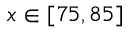<formula> <loc_0><loc_0><loc_500><loc_500>x \in [ 7 5 , 8 5 ]</formula> 